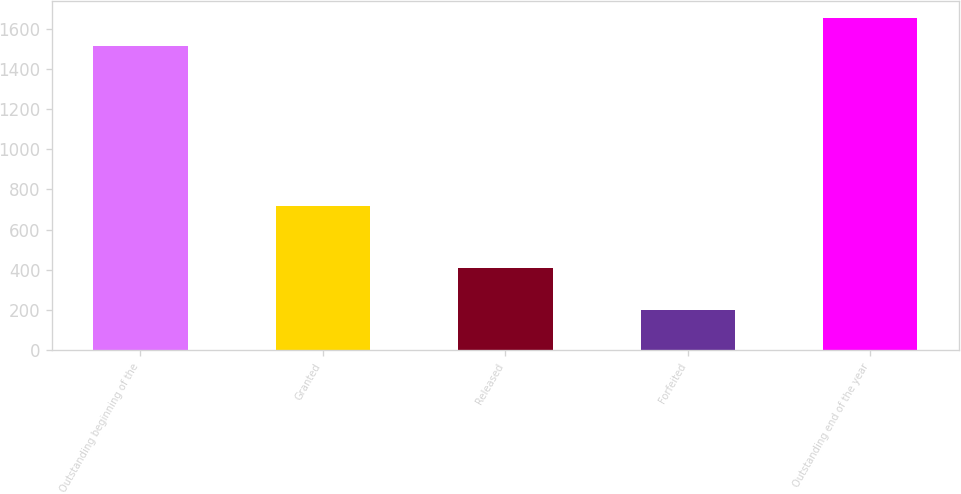Convert chart. <chart><loc_0><loc_0><loc_500><loc_500><bar_chart><fcel>Outstanding beginning of the<fcel>Granted<fcel>Released<fcel>Forfeited<fcel>Outstanding end of the year<nl><fcel>1513<fcel>716<fcel>411<fcel>202<fcel>1654.4<nl></chart> 